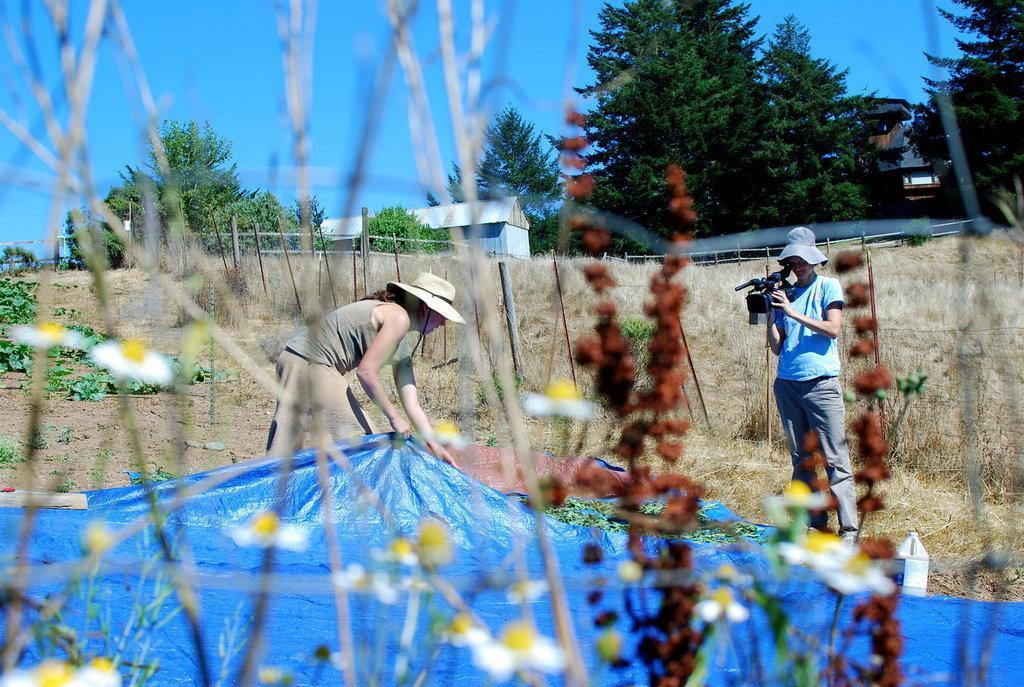Describe this image in one or two sentences. This picture might be taken from outside of the city. In this image, on the right side, we can see a person holding a camera. In the middle of the image, we can see a woman wearing a hat and holding blue color mat in her hand. In the background, we can see some trees, houseplant with some flowers, net fence. at the top, we can see a sky, at the bottom there is a land with some stones and a grass. 